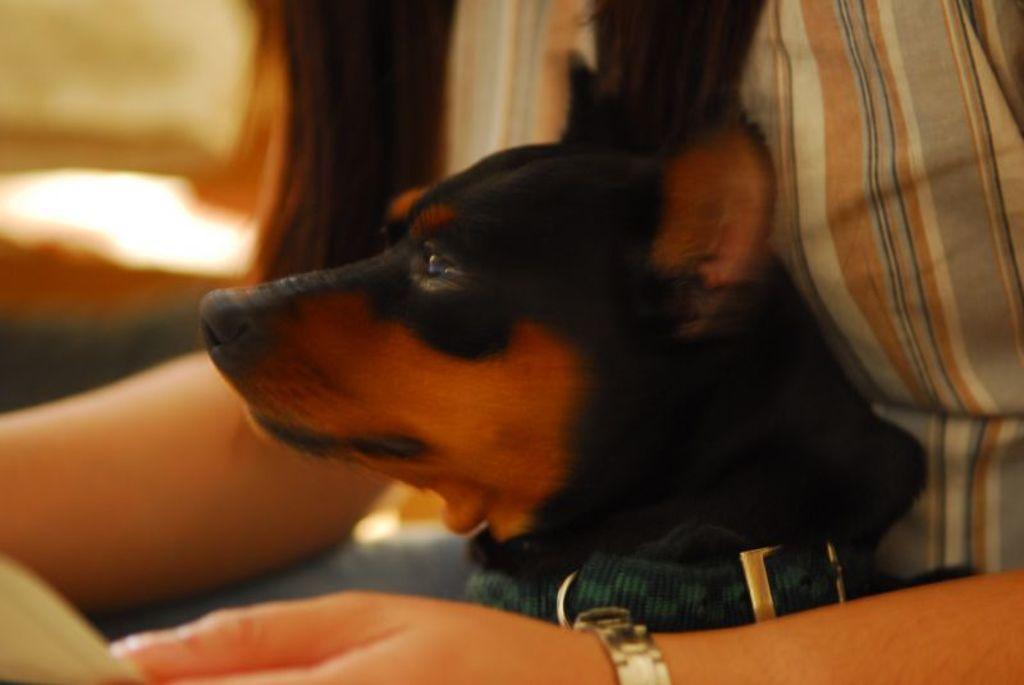Could you give a brief overview of what you see in this image? In this picture we can see a woman and a dog. 